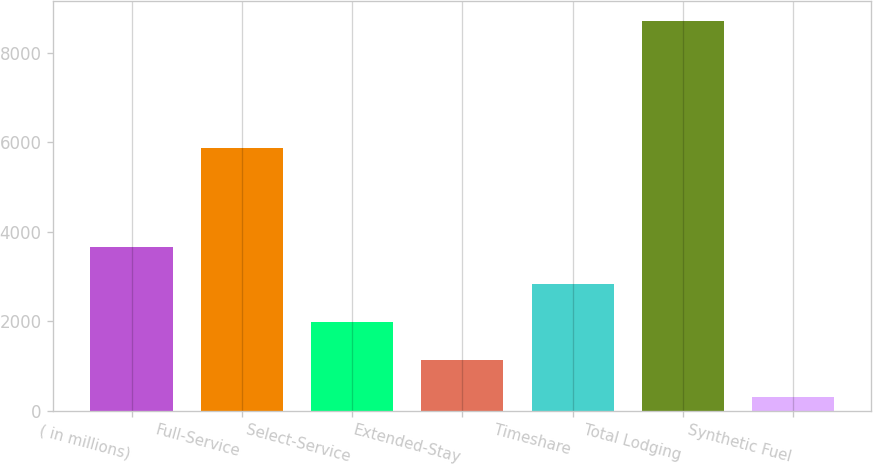<chart> <loc_0><loc_0><loc_500><loc_500><bar_chart><fcel>( in millions)<fcel>Full-Service<fcel>Select-Service<fcel>Extended-Stay<fcel>Timeshare<fcel>Total Lodging<fcel>Synthetic Fuel<nl><fcel>3666<fcel>5876<fcel>1984<fcel>1143<fcel>2825<fcel>8712<fcel>302<nl></chart> 